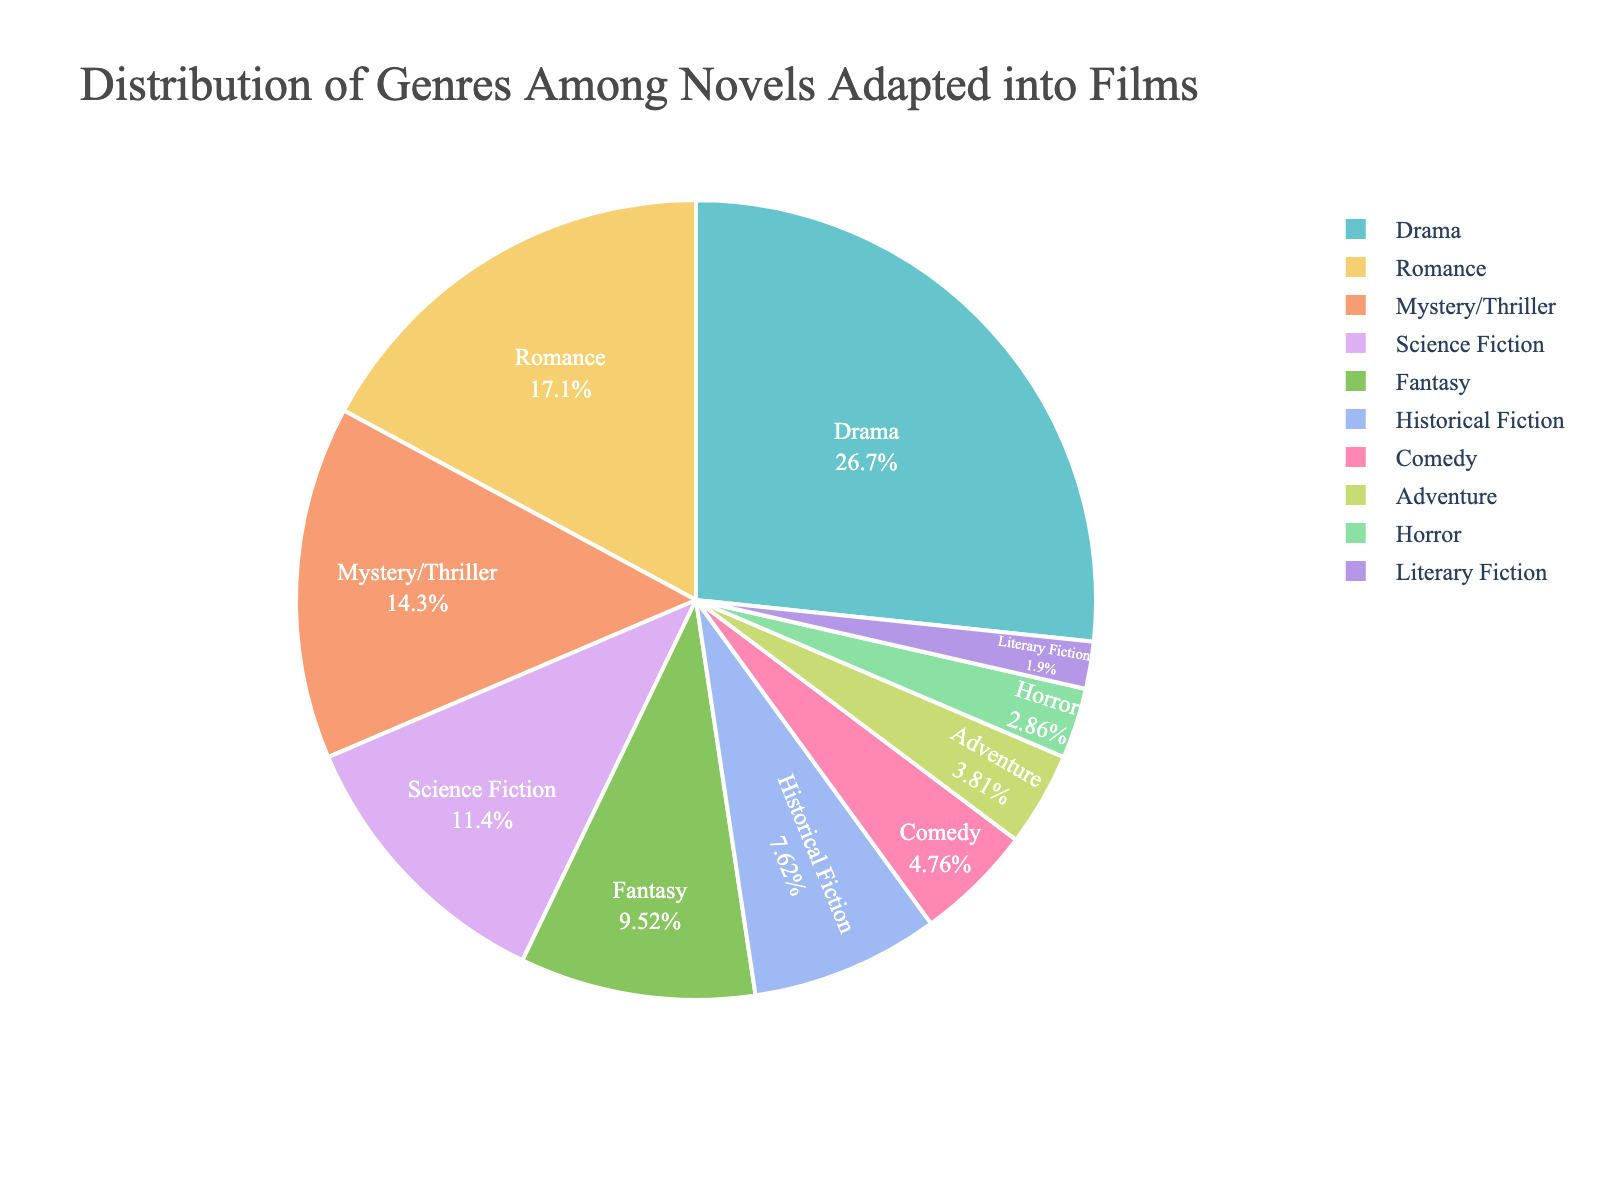What's the most common genre among novels adapted into films? The pie chart shows that Drama has the largest slice, indicating it's the most common genre among the adapted novels.
Answer: Drama What's the least common genre present in the pie chart? The pie chart shows that Literary Fiction has the smallest slice, indicating it's the least common genre among the adapted novels.
Answer: Literary Fiction Which genres together make up more than 50% of the adapted novels? Adding up the top percentages: Drama (28%) + Romance (18%) = 46%, which is still less than 50%. Adding Mystery/Thriller next: 46% + 15% = 61%, which is above 50%. Therefore, Drama, Romance, and Mystery/Thriller together make up more than 50% of the adapted novels.
Answer: Drama, Romance, Mystery/Thriller How much more prevalent is Drama compared to Comedy? The percentage for Drama is 28% while for Comedy it is 5%. Subtracting the two values: 28% - 5% = 23%.
Answer: 23% What is the combined percentage of Science Fiction and Fantasy genres? Adding the two percentages: Science Fiction (12%) + Fantasy (10%) = 22%.
Answer: 22% Which genres have a higher percentage than Historical Fiction? Historical Fiction has a percentage of 8%. The genres with a higher percentage are Drama (28%), Romance (18%), Mystery/Thriller (15%), Science Fiction (12%), and Fantasy (10%).
Answer: Drama, Romance, Mystery/Thriller, Science Fiction, Fantasy Is the percentage of Adventure novels higher than that of Horror novels? The pie chart shows Adventure at 4% and Horror at 3%. Since 4% is greater than 3%, Adventure has a higher percentage than Horror.
Answer: Yes What is the total percentage of all genres combined other than Drama? Total percentage for all genres is 100%. Subtract the percentage of Drama: 100% - 28% = 72%.
Answer: 72% How does the percentage of Romance novels compare to the combined percentage of Comedy, Adventure, and Horror? Adding the percentages of Comedy (5%), Adventure (4%), and Horror (3%) gives 5% + 4% + 3% = 12%. Romance is 18%, so Romance (18%) > 12%.
Answer: Romance is higher What is the percentage difference between Science Fiction and Historical Fiction? The percentage for Science Fiction is 12% and for Historical Fiction it is 8%. Subtracting the two percentages: 12% - 8% = 4%.
Answer: 4% 